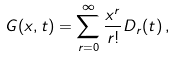Convert formula to latex. <formula><loc_0><loc_0><loc_500><loc_500>G ( x , t ) = \sum _ { r = 0 } ^ { \infty } \frac { x ^ { r } } { r ! } D _ { r } ( t ) \, ,</formula> 